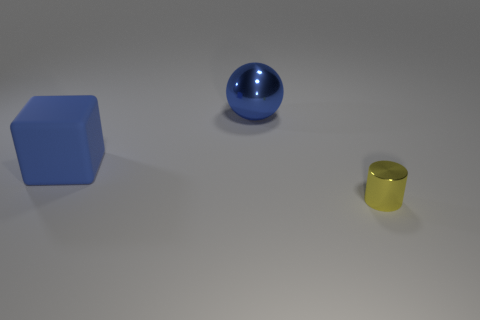Is there a large blue shiny thing of the same shape as the large blue rubber thing?
Your response must be concise. No. What number of objects are either things in front of the large blue shiny ball or big blue metal things?
Provide a short and direct response. 3. Are there more large metal spheres than small brown metallic cubes?
Provide a succinct answer. Yes. Is there a blue rubber cube of the same size as the yellow metal object?
Make the answer very short. No. What number of things are objects that are to the left of the yellow metallic object or objects in front of the big blue shiny ball?
Provide a succinct answer. 3. What is the color of the object that is in front of the object on the left side of the ball?
Your response must be concise. Yellow. The sphere that is made of the same material as the cylinder is what color?
Your response must be concise. Blue. How many big rubber cubes are the same color as the tiny shiny object?
Your answer should be very brief. 0. What number of objects are big objects or yellow shiny cylinders?
Ensure brevity in your answer.  3. The blue object that is the same size as the blue rubber block is what shape?
Your answer should be compact. Sphere. 